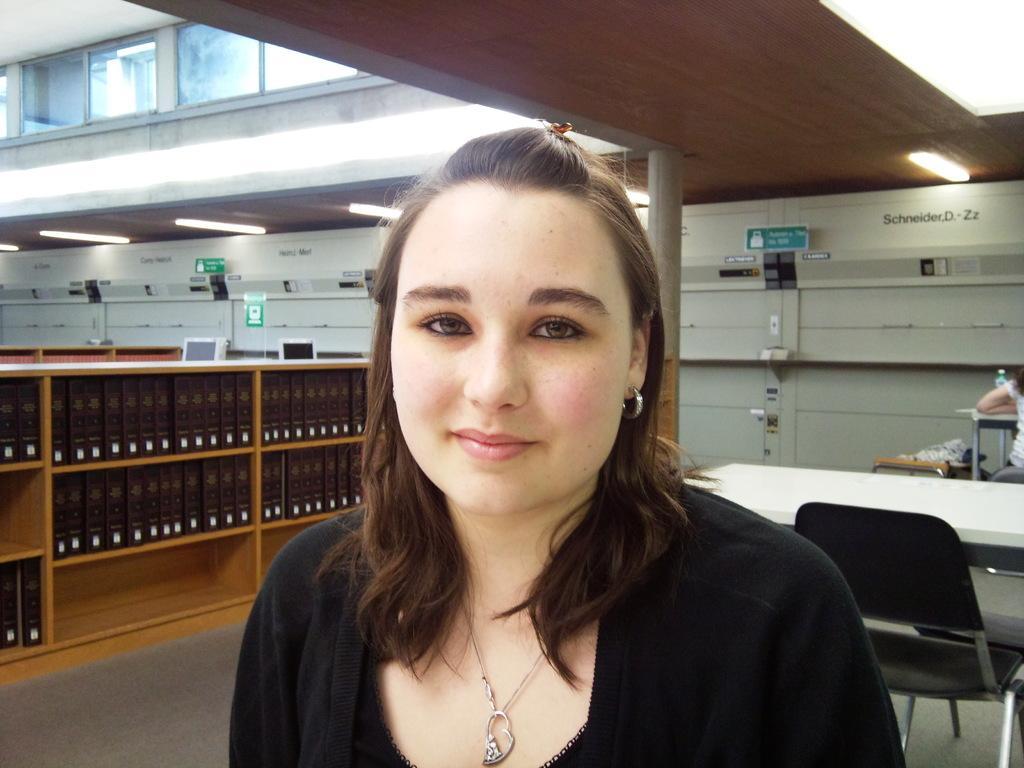Describe this image in one or two sentences. In this picture there is a woman who is wearing locket and black dress. In the back we can see table and chairs. On the right there is another woman who is sitting on the chair and wearing white dress. Here it's a light. On the left we can see tube light, sign boards and other objects. On the top left corner we can see windows. On the bottom left we can see many books which are kept in this wooden rack. 